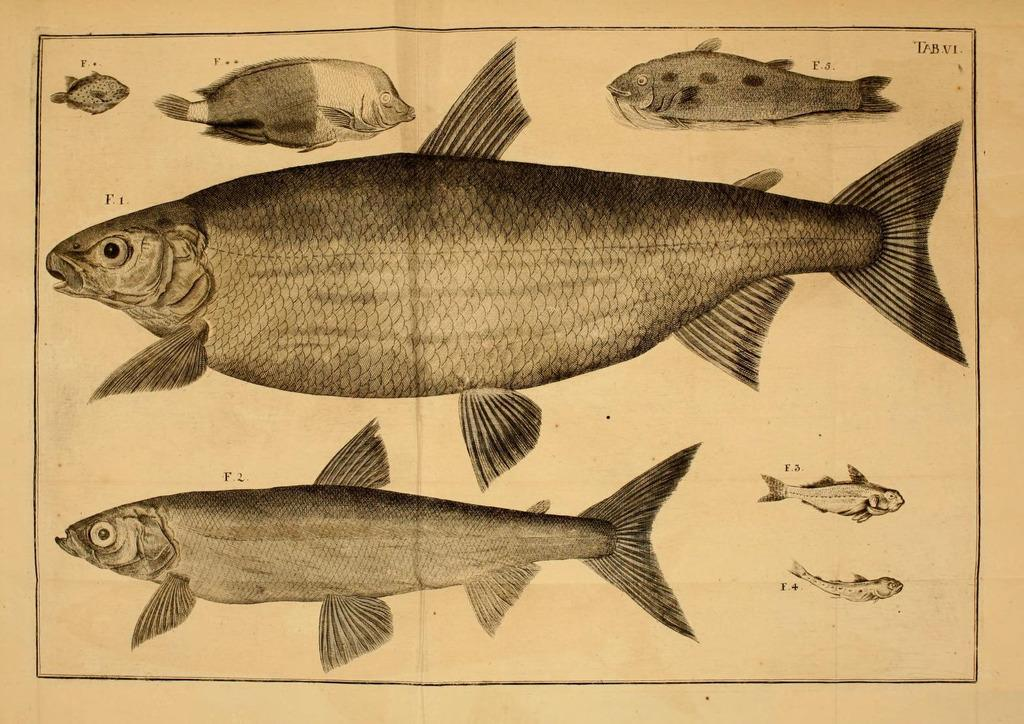How many fishes are present in the image? There are seven fishes in the image. What is the color of the background in the image? The background behind the fishes is white. What type of mint can be seen growing near the fishes in the image? There is no mint present in the image; it only features seven fishes against a white background. 